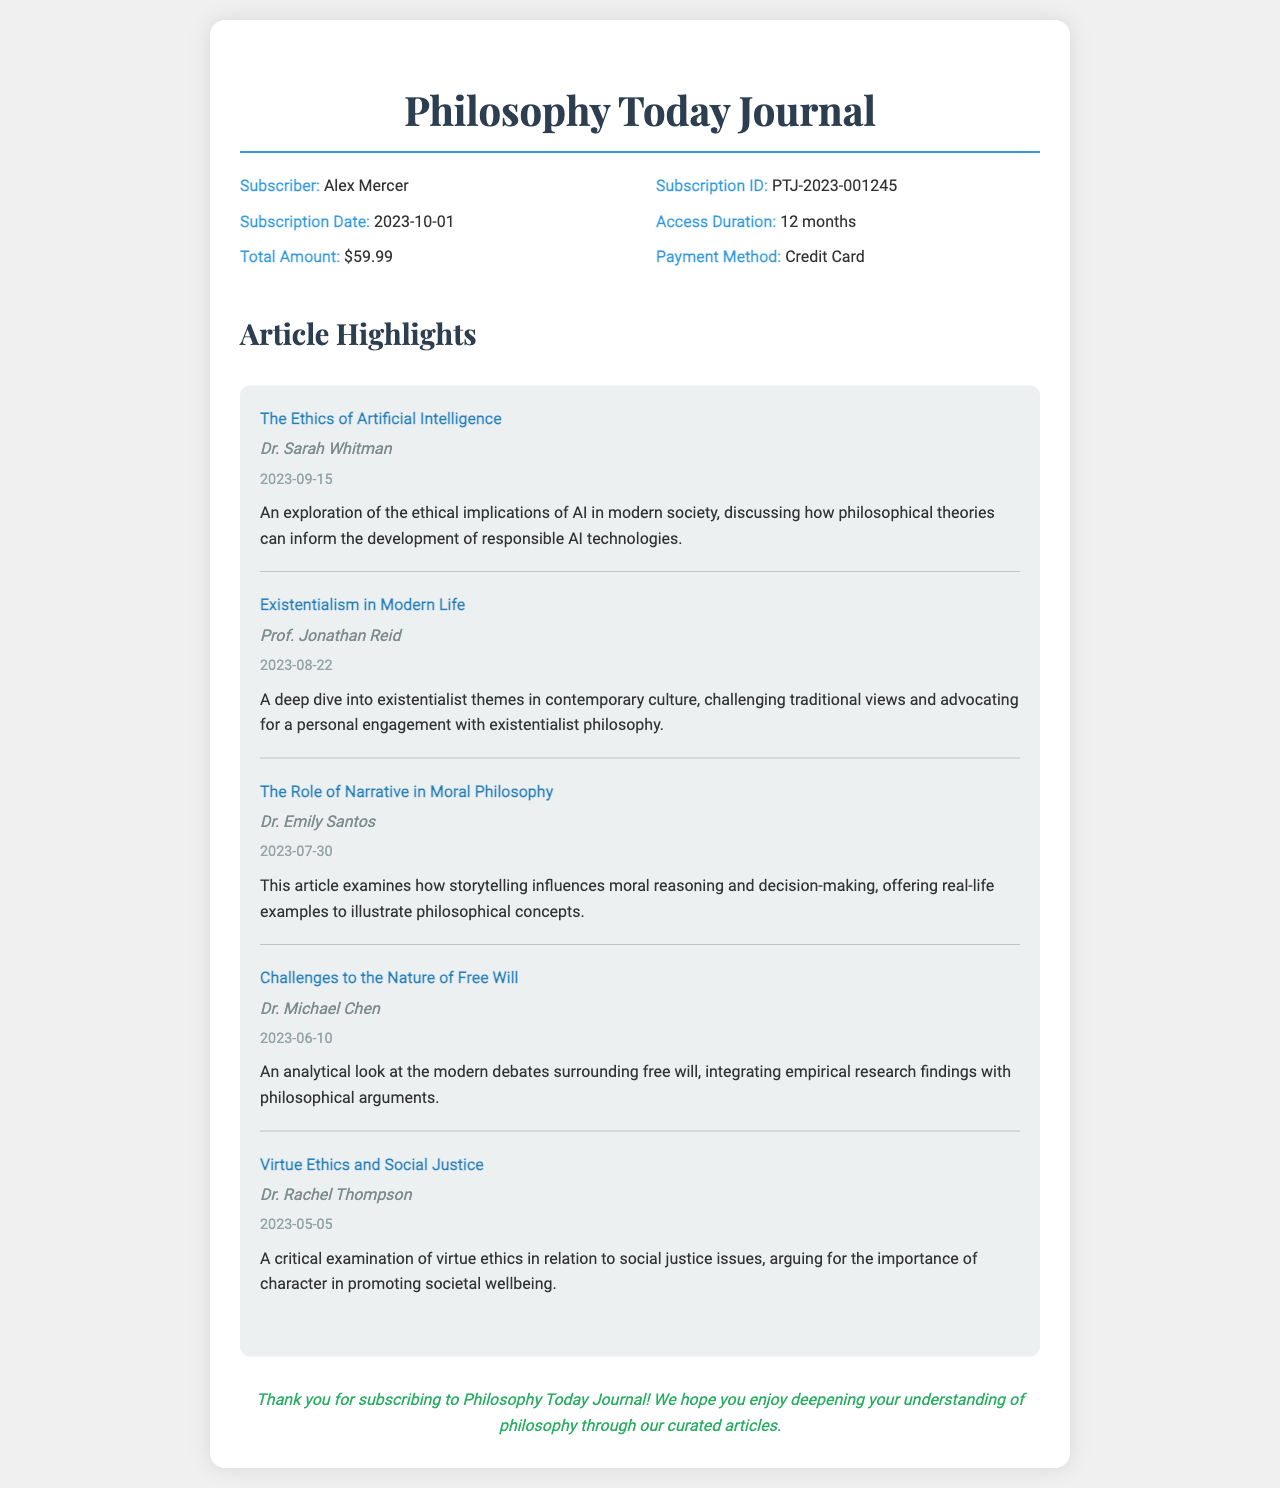What is the name of the subscriber? The subscriber's name is located in the header section of the receipt.
Answer: Alex Mercer What is the subscription ID? The unique identifier for the subscription can be found in the information section.
Answer: PTJ-2023-001245 When was the subscription date? The subscription date is indicated under subscription information.
Answer: 2023-10-01 What is the access duration for the journal? The access duration detail is specified in the receipt's information section.
Answer: 12 months What is the total amount for the subscription? The total amount charged for the subscription is listed in the receipt.
Answer: $59.99 Who authored the article "The Ethics of Artificial Intelligence"? The author information for the specific article is stated in the highlights section.
Answer: Dr. Sarah Whitman What theme is explored in "Existentialism in Modern Life"? The exploration theme is mentioned in the article summary section.
Answer: Existentialist themes What type of payment method was used for the subscription? The payment method is indicated in the information section of the receipt.
Answer: Credit Card How many articles are highlighted in this subscription receipt? The number of highlighted articles can be counted in the highlights section.
Answer: 5 